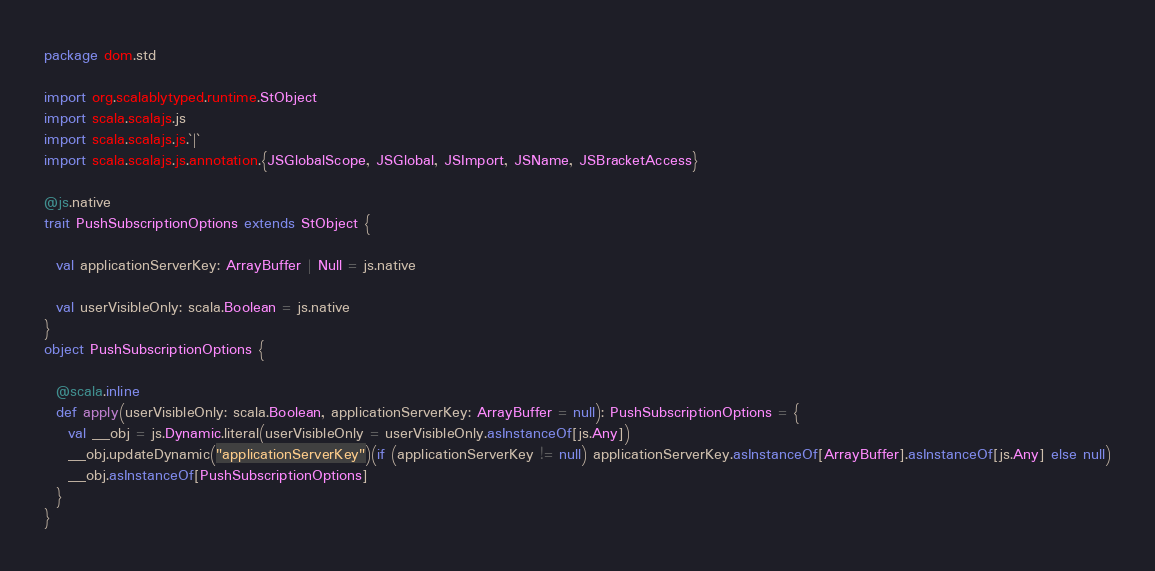<code> <loc_0><loc_0><loc_500><loc_500><_Scala_>package dom.std

import org.scalablytyped.runtime.StObject
import scala.scalajs.js
import scala.scalajs.js.`|`
import scala.scalajs.js.annotation.{JSGlobalScope, JSGlobal, JSImport, JSName, JSBracketAccess}

@js.native
trait PushSubscriptionOptions extends StObject {
  
  val applicationServerKey: ArrayBuffer | Null = js.native
  
  val userVisibleOnly: scala.Boolean = js.native
}
object PushSubscriptionOptions {
  
  @scala.inline
  def apply(userVisibleOnly: scala.Boolean, applicationServerKey: ArrayBuffer = null): PushSubscriptionOptions = {
    val __obj = js.Dynamic.literal(userVisibleOnly = userVisibleOnly.asInstanceOf[js.Any])
    __obj.updateDynamic("applicationServerKey")(if (applicationServerKey != null) applicationServerKey.asInstanceOf[ArrayBuffer].asInstanceOf[js.Any] else null)
    __obj.asInstanceOf[PushSubscriptionOptions]
  }
}
</code> 